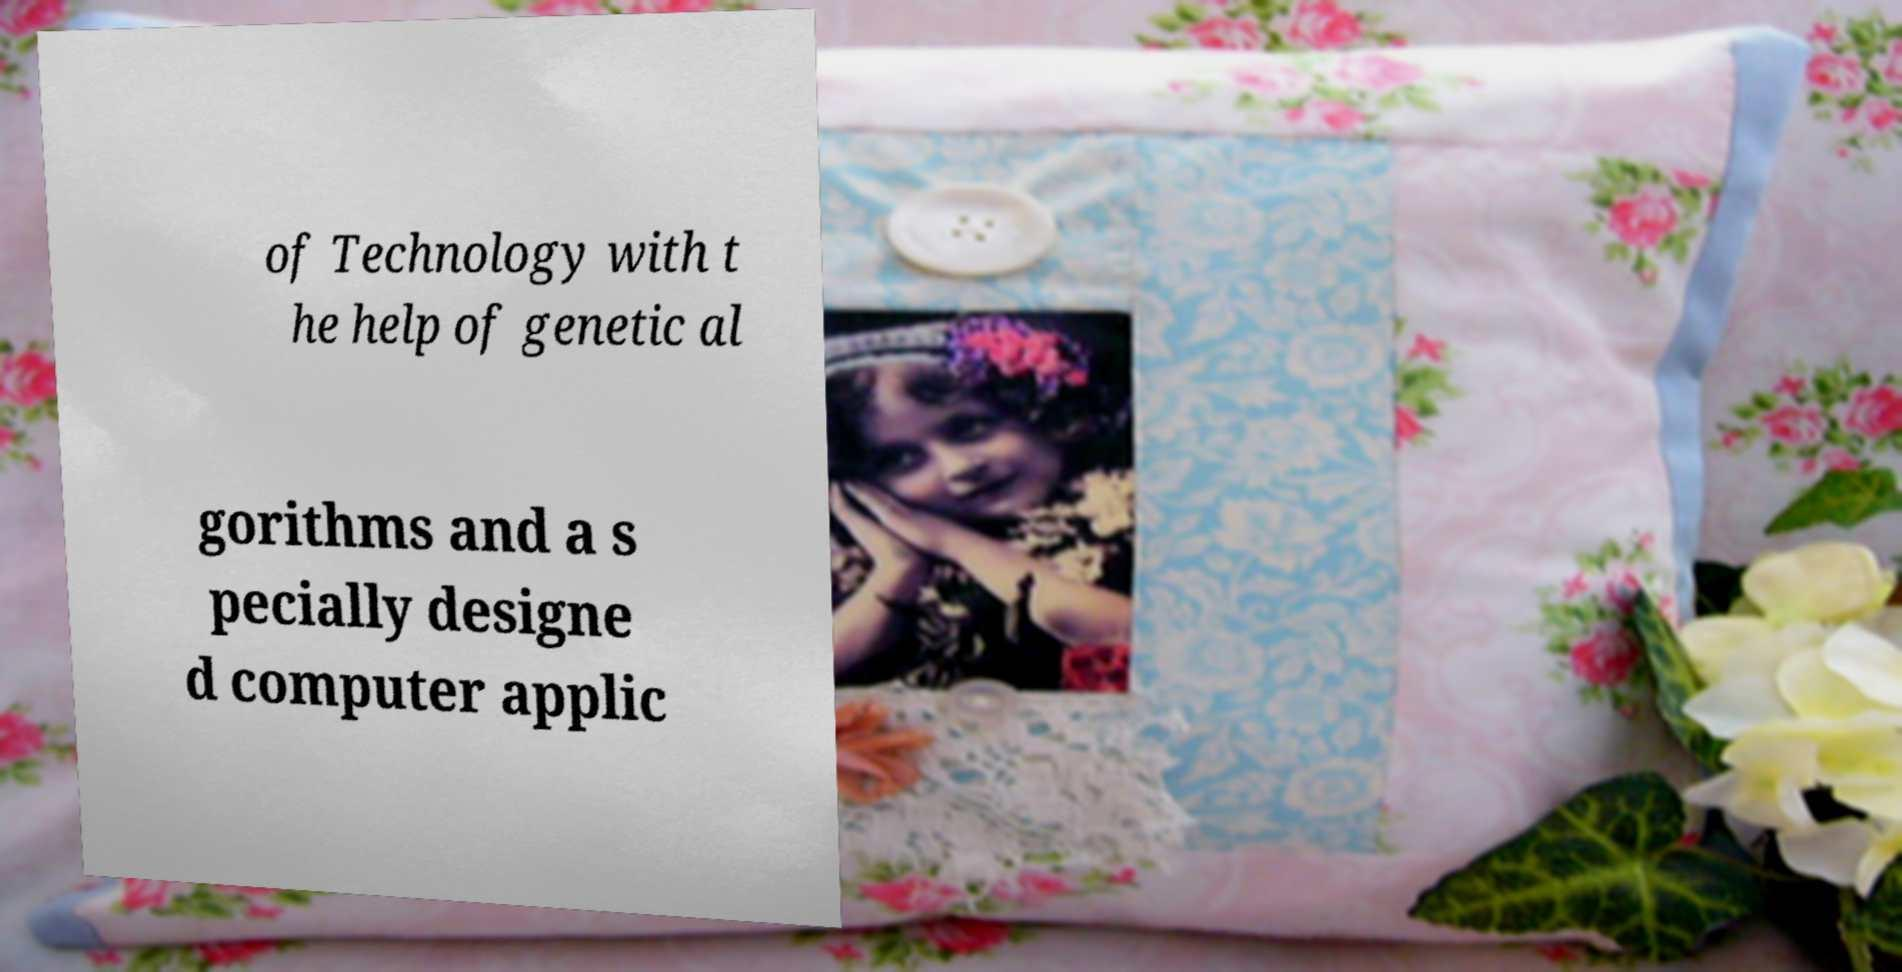I need the written content from this picture converted into text. Can you do that? of Technology with t he help of genetic al gorithms and a s pecially designe d computer applic 